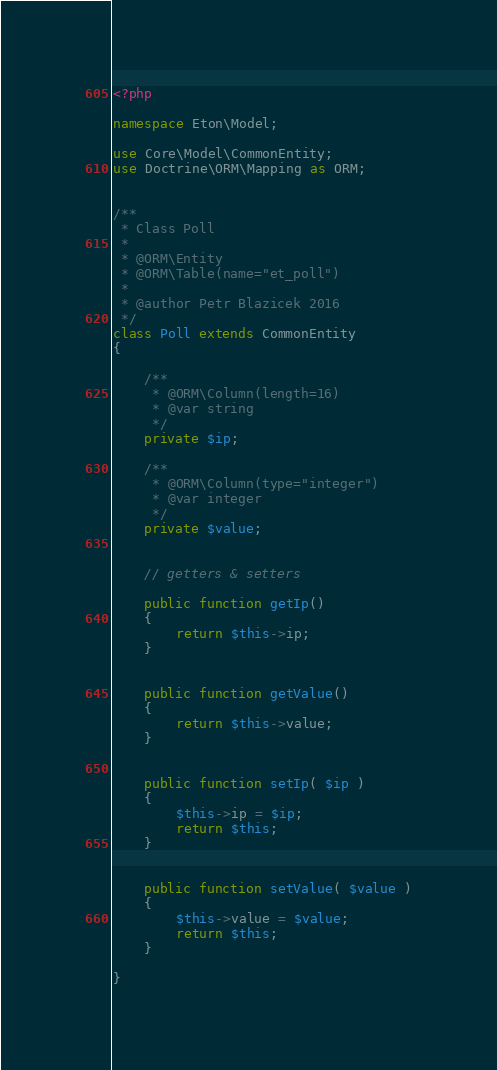Convert code to text. <code><loc_0><loc_0><loc_500><loc_500><_PHP_><?php

namespace Eton\Model;

use Core\Model\CommonEntity;
use Doctrine\ORM\Mapping as ORM;


/**
 * Class Poll
 * 
 * @ORM\Entity
 * @ORM\Table(name="et_poll")
 * 
 * @author Petr Blazicek 2016
 */
class Poll extends CommonEntity
{

	/**
	 * @ORM\Column(length=16)
	 * @var string
	 */
	private $ip;

	/**
	 * @ORM\Column(type="integer")
	 * @var integer
	 */
	private $value;


	// getters & setters

	public function getIp()
	{
		return $this->ip;
	}


	public function getValue()
	{
		return $this->value;
	}


	public function setIp( $ip )
	{
		$this->ip = $ip;
		return $this;
	}


	public function setValue( $value )
	{
		$this->value = $value;
		return $this;
	}

}
</code> 